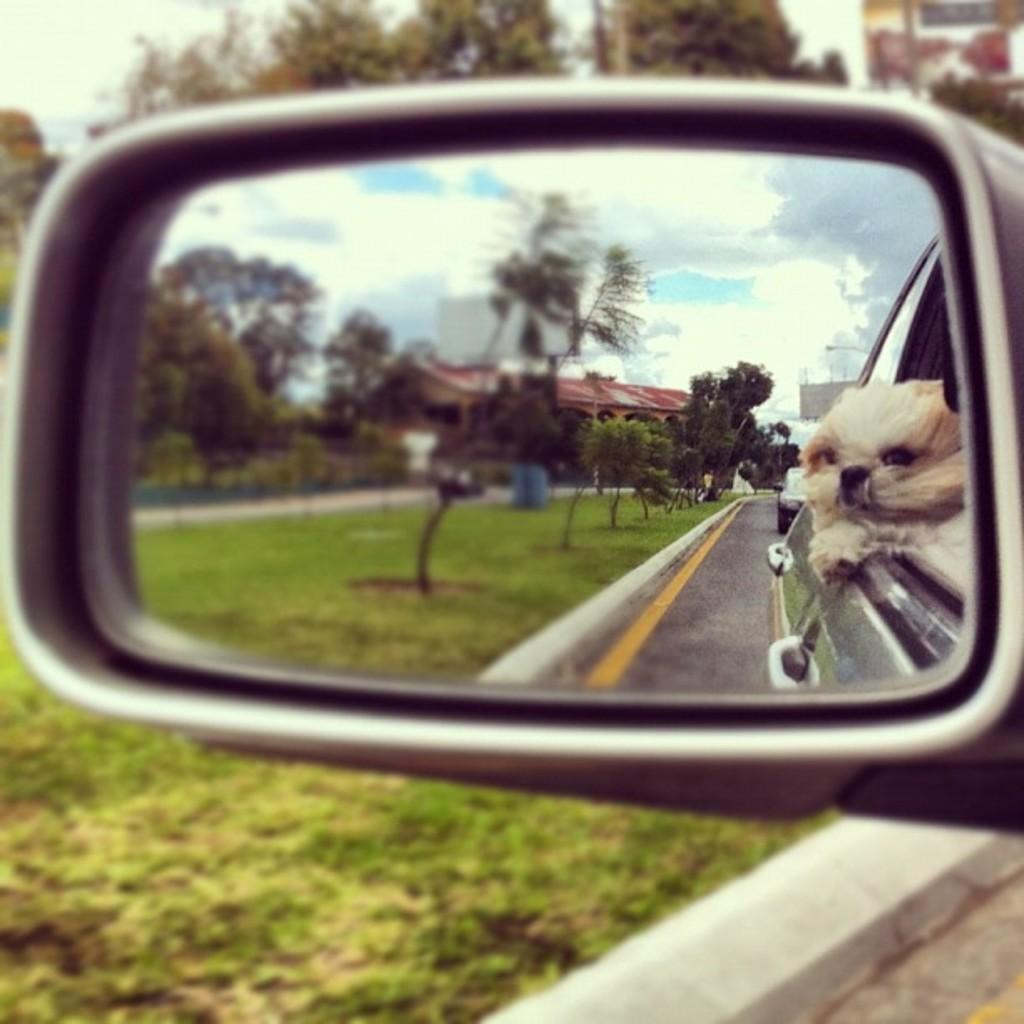What is the main subject of the image? The main subject of the image is a car mirror. What does the car mirror reflect in the image? The car mirror reflects a dog, trees, a building, and the sky in the image. What can be seen in the background of the image? In the background of the image, there are trees and grass. What type of sun is visible in the image? There is no sun visible in the image; the car mirror reflects the sky, but not the sun. Can you tell me how many carriages are present in the image? There are no carriages present in the image; the main subject is a car mirror. 